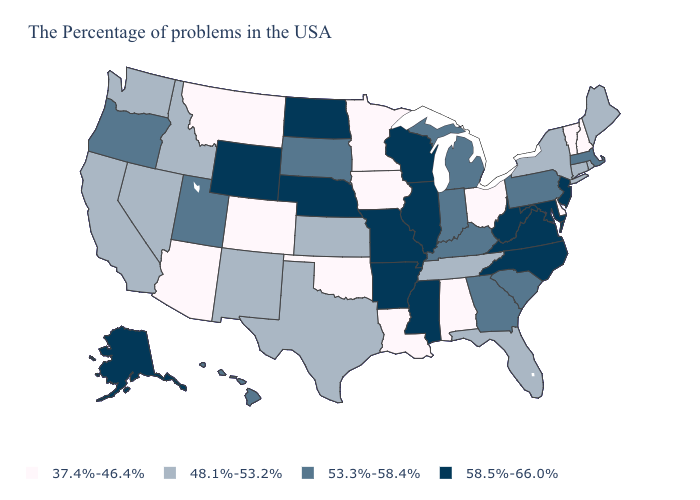Does the first symbol in the legend represent the smallest category?
Write a very short answer. Yes. Does Alabama have the lowest value in the USA?
Quick response, please. Yes. What is the lowest value in the MidWest?
Short answer required. 37.4%-46.4%. What is the value of Colorado?
Be succinct. 37.4%-46.4%. What is the value of Washington?
Concise answer only. 48.1%-53.2%. What is the value of Louisiana?
Answer briefly. 37.4%-46.4%. Does the first symbol in the legend represent the smallest category?
Short answer required. Yes. What is the value of Virginia?
Keep it brief. 58.5%-66.0%. Does the first symbol in the legend represent the smallest category?
Short answer required. Yes. Does the map have missing data?
Be succinct. No. Name the states that have a value in the range 48.1%-53.2%?
Write a very short answer. Maine, Rhode Island, Connecticut, New York, Florida, Tennessee, Kansas, Texas, New Mexico, Idaho, Nevada, California, Washington. What is the value of Texas?
Answer briefly. 48.1%-53.2%. What is the value of Vermont?
Concise answer only. 37.4%-46.4%. Name the states that have a value in the range 53.3%-58.4%?
Answer briefly. Massachusetts, Pennsylvania, South Carolina, Georgia, Michigan, Kentucky, Indiana, South Dakota, Utah, Oregon, Hawaii. Does North Carolina have the highest value in the USA?
Be succinct. Yes. 